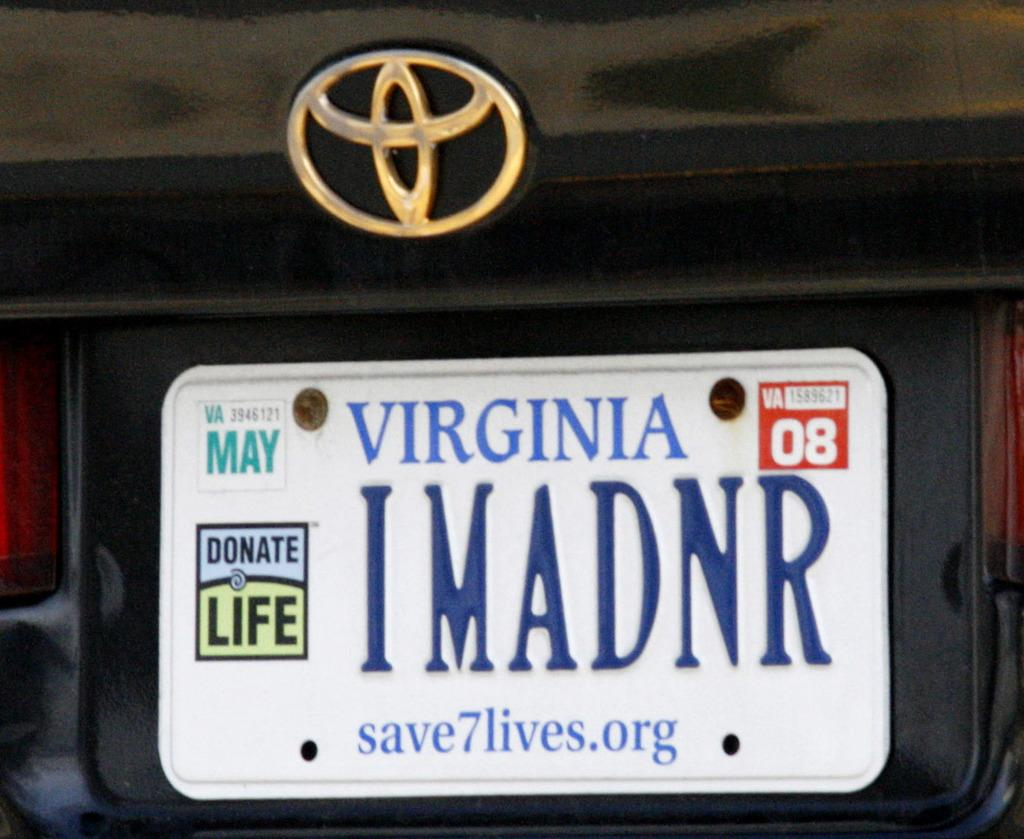<image>
Offer a succinct explanation of the picture presented. A Virginia licence plate with the number 08 visible. 